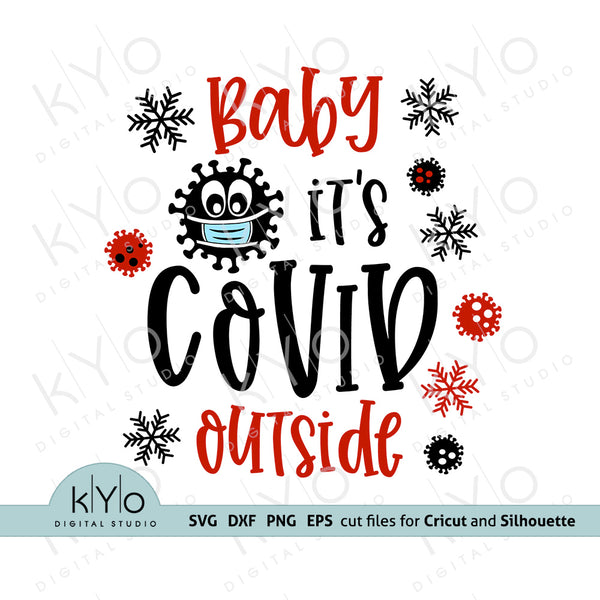Considering the details of the graphic design, what is the likely purpose of this image, and what cultural or societal context does it reference? The image is likely designed for use as a digital cut file for personal crafting machines like Cricut and Silhouette, intended for creating physical items such as t-shirts, mugs, or decorations. The phrase "Baby it's COVID outside" is a play on the classic holiday song "Baby, It's Cold Outside," with a contemporary twist referencing the COVID-19 pandemic. The inclusion of snowflakes suggests a winter or holiday theme, while the anthropomorphized virus particle with a mask reflects the widespread public health measures during the pandemic. The cultural context implies a humorous or light-hearted commentary on the impact of the COVID-19 pandemic on typical holiday experiences. 